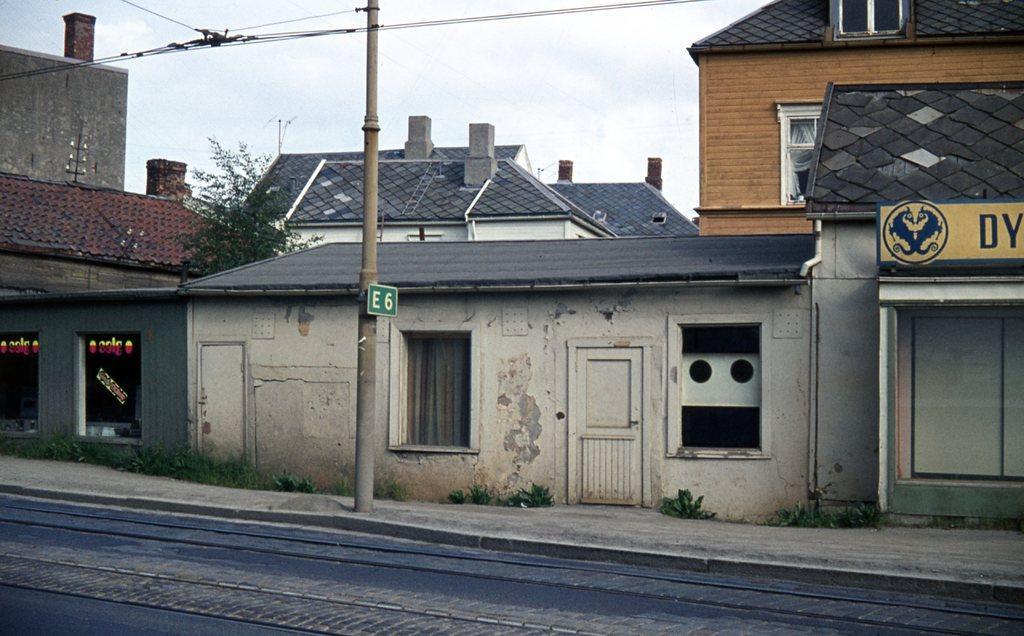Please provide a concise description of this image. At the bottom we can see a road. In the background there are buildings,windows,curtains,text written on the glass doors,door,tree,electric pole,wires,hoarding on the right side,some other objects and clouds in the sky. 